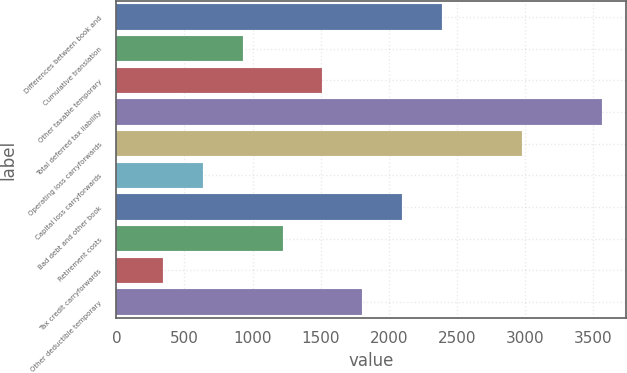Convert chart. <chart><loc_0><loc_0><loc_500><loc_500><bar_chart><fcel>Differences between book and<fcel>Cumulative translation<fcel>Other taxable temporary<fcel>Total deferred tax liability<fcel>Operating loss carryforwards<fcel>Capital loss carryforwards<fcel>Bad debt and other book<fcel>Retirement costs<fcel>Tax credit carryforwards<fcel>Other deductible temporary<nl><fcel>2390.4<fcel>926.4<fcel>1512<fcel>3561.6<fcel>2976<fcel>633.6<fcel>2097.6<fcel>1219.2<fcel>340.8<fcel>1804.8<nl></chart> 